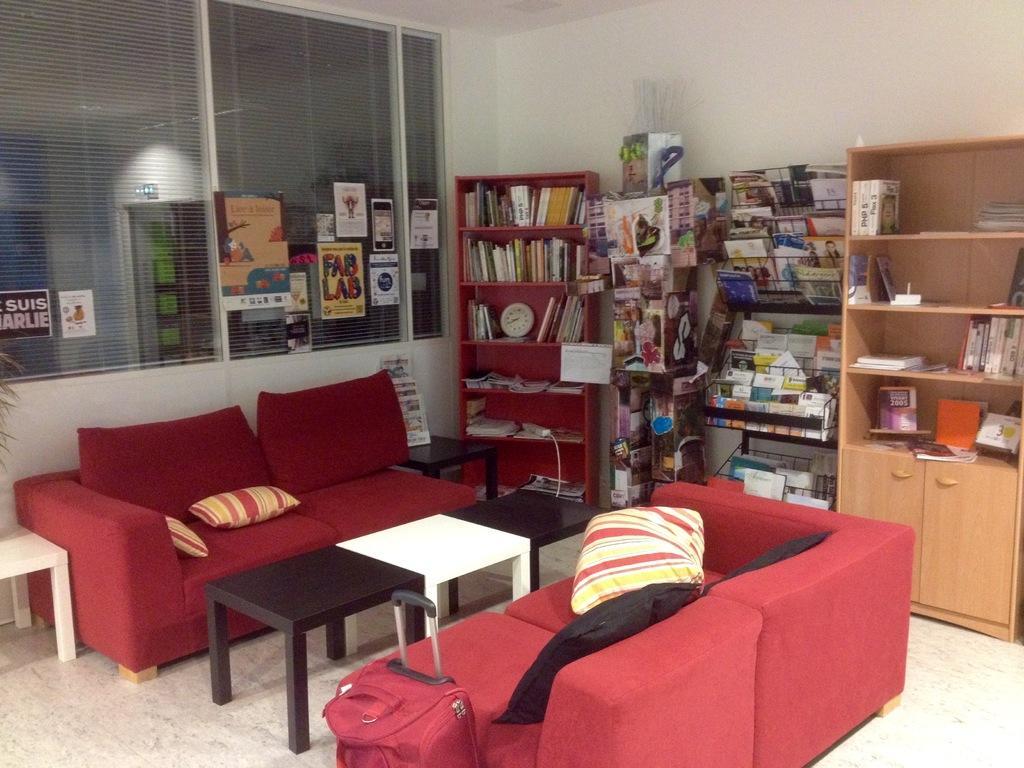How would you summarize this image in a sentence or two? In the image I can see some sofas on which there are some pillows, tables and some shelves in which there are some books and some other things arranged. 